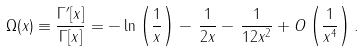<formula> <loc_0><loc_0><loc_500><loc_500>\Omega ( x ) \equiv \frac { \Gamma ^ { \prime } [ x ] } { \Gamma [ x ] } = - \ln \left ( \frac { 1 } { x } \right ) - \, \frac { 1 } { 2 x } - \, \frac { 1 } { 1 2 x ^ { 2 } } + O \left ( \frac { 1 } { x ^ { 4 } } \right ) .</formula> 